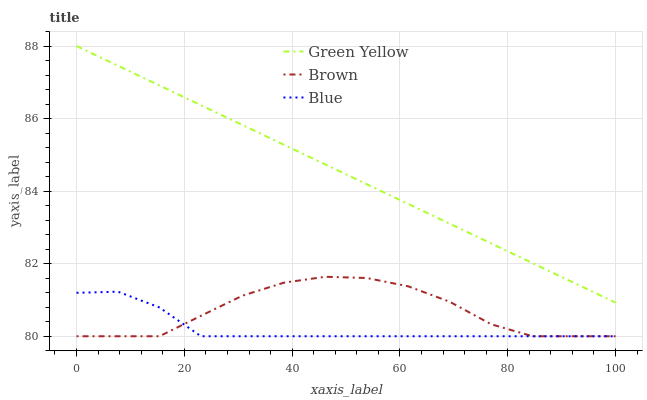Does Blue have the minimum area under the curve?
Answer yes or no. Yes. Does Green Yellow have the maximum area under the curve?
Answer yes or no. Yes. Does Brown have the minimum area under the curve?
Answer yes or no. No. Does Brown have the maximum area under the curve?
Answer yes or no. No. Is Green Yellow the smoothest?
Answer yes or no. Yes. Is Brown the roughest?
Answer yes or no. Yes. Is Brown the smoothest?
Answer yes or no. No. Is Green Yellow the roughest?
Answer yes or no. No. Does Blue have the lowest value?
Answer yes or no. Yes. Does Green Yellow have the lowest value?
Answer yes or no. No. Does Green Yellow have the highest value?
Answer yes or no. Yes. Does Brown have the highest value?
Answer yes or no. No. Is Blue less than Green Yellow?
Answer yes or no. Yes. Is Green Yellow greater than Brown?
Answer yes or no. Yes. Does Blue intersect Brown?
Answer yes or no. Yes. Is Blue less than Brown?
Answer yes or no. No. Is Blue greater than Brown?
Answer yes or no. No. Does Blue intersect Green Yellow?
Answer yes or no. No. 